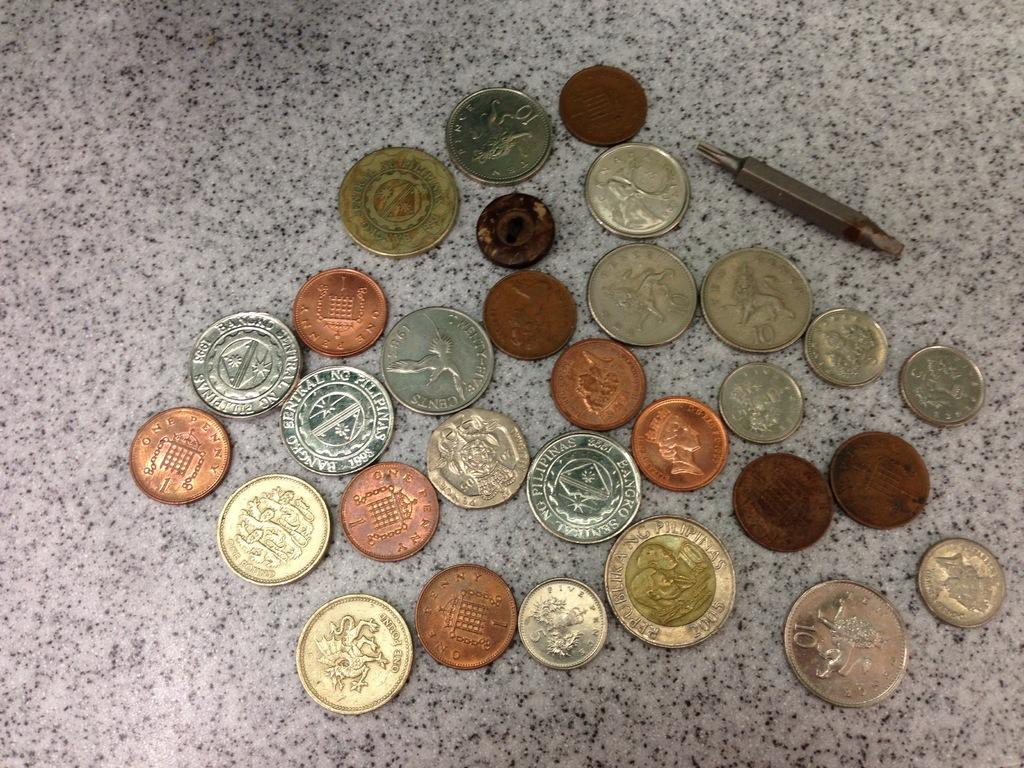<image>
Offer a succinct explanation of the picture presented. A collection of coins that includes a one pound coin and a five pence coin. 